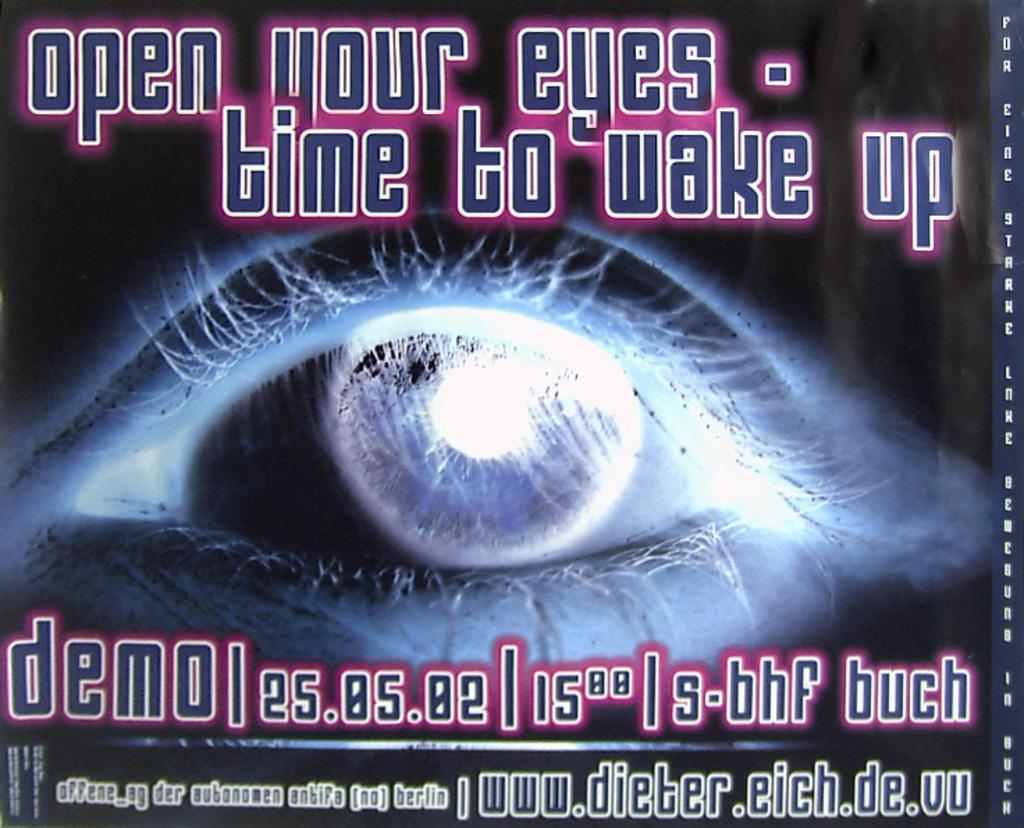<image>
Give a short and clear explanation of the subsequent image. A poster with a close up image of a person's eye, glowing blue, says open your eyes- time to wake up. 